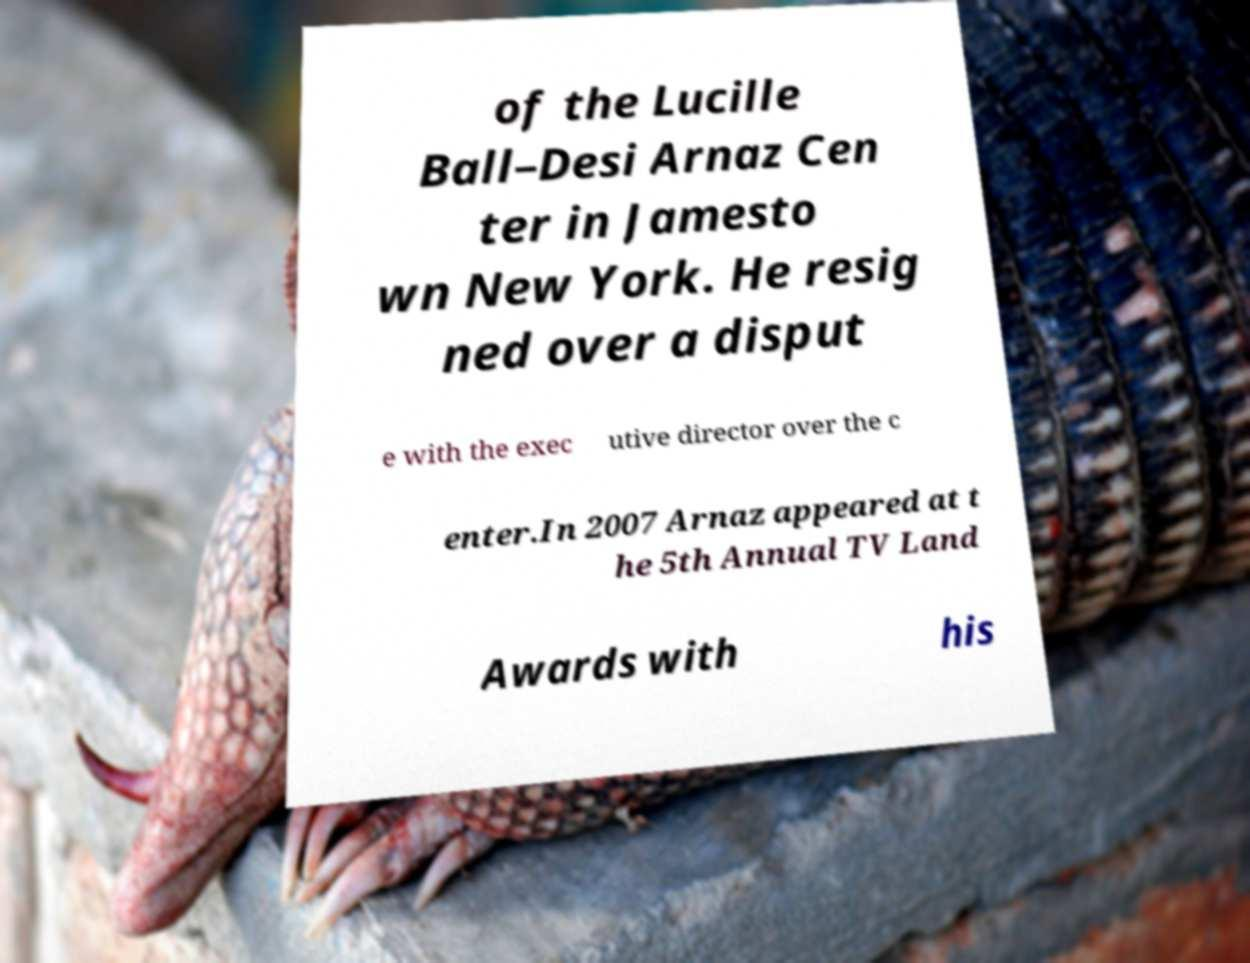Could you assist in decoding the text presented in this image and type it out clearly? of the Lucille Ball–Desi Arnaz Cen ter in Jamesto wn New York. He resig ned over a disput e with the exec utive director over the c enter.In 2007 Arnaz appeared at t he 5th Annual TV Land Awards with his 